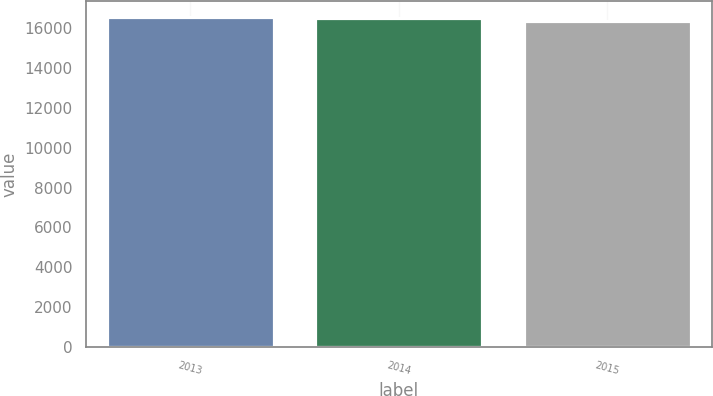Convert chart. <chart><loc_0><loc_0><loc_500><loc_500><bar_chart><fcel>2013<fcel>2014<fcel>2015<nl><fcel>16536<fcel>16503<fcel>16340<nl></chart> 